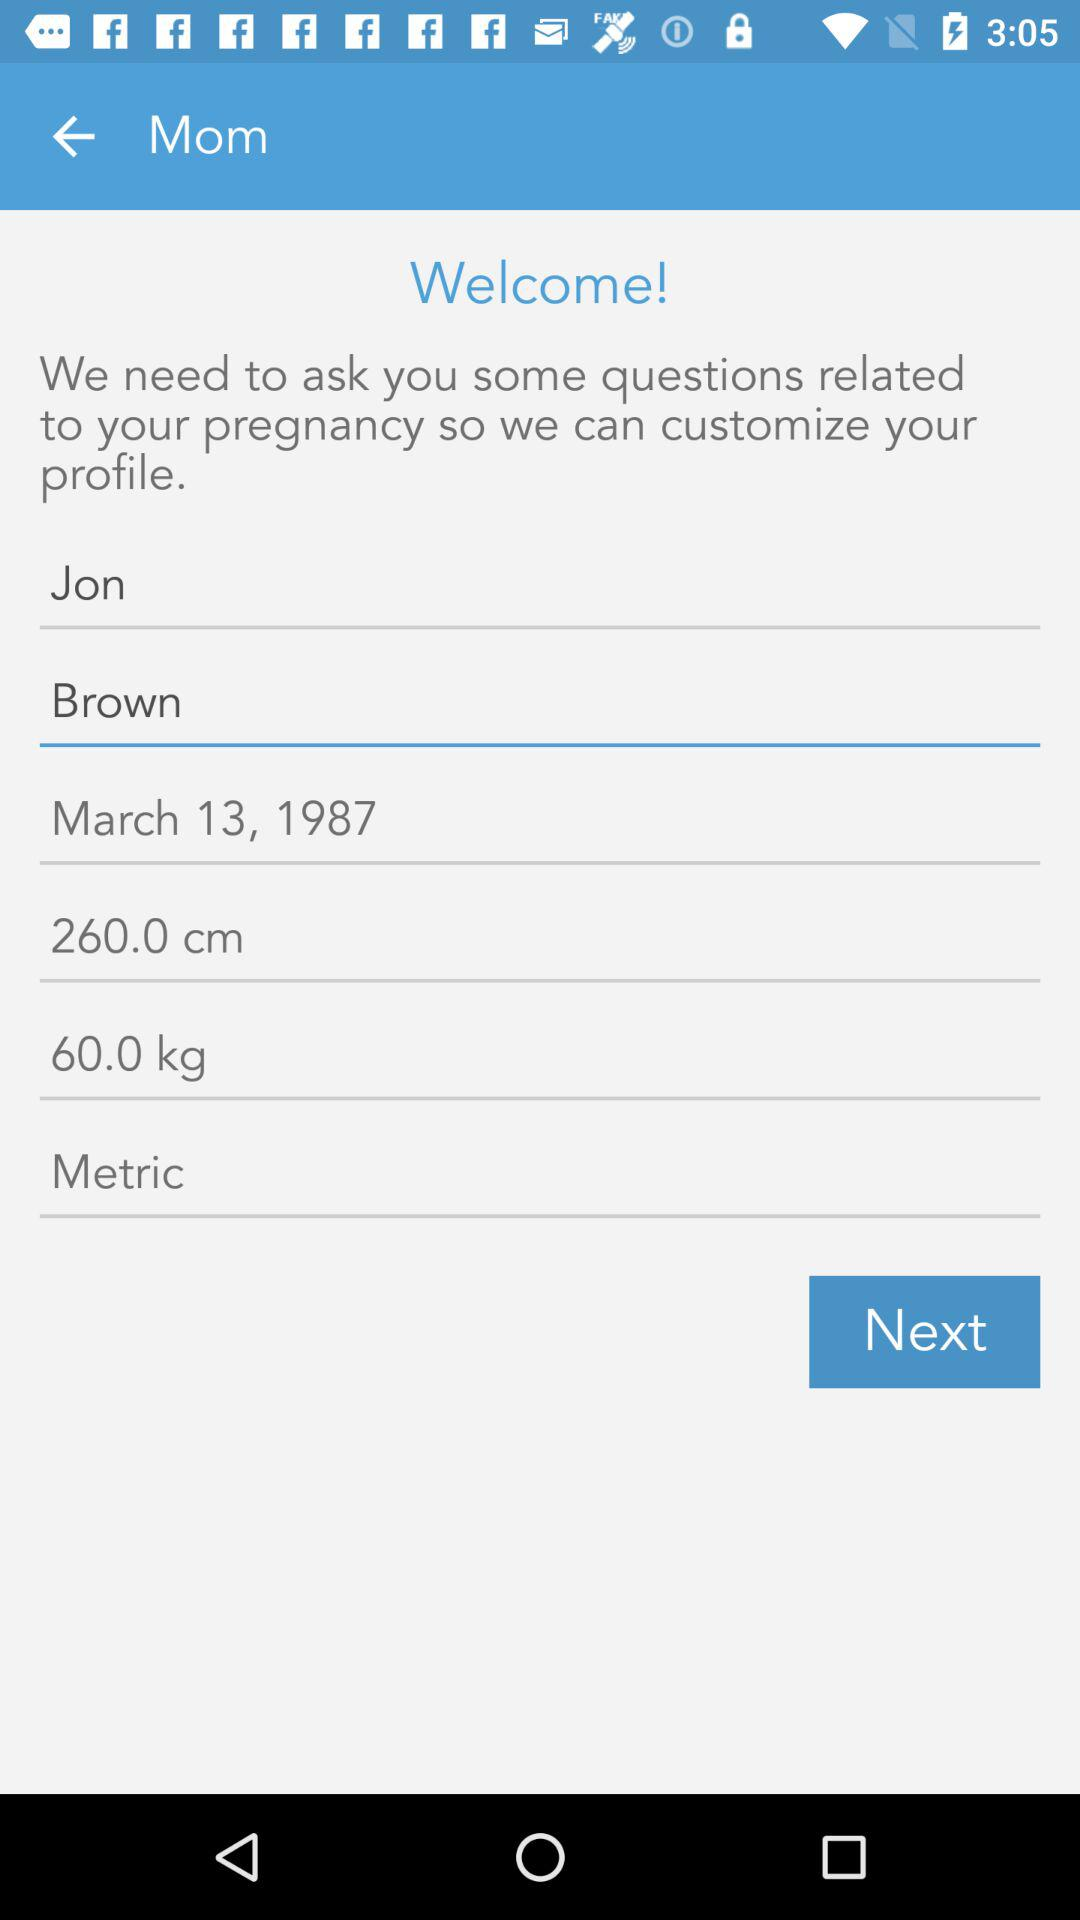What is the user's qualification?
When the provided information is insufficient, respond with <no answer>. <no answer> 